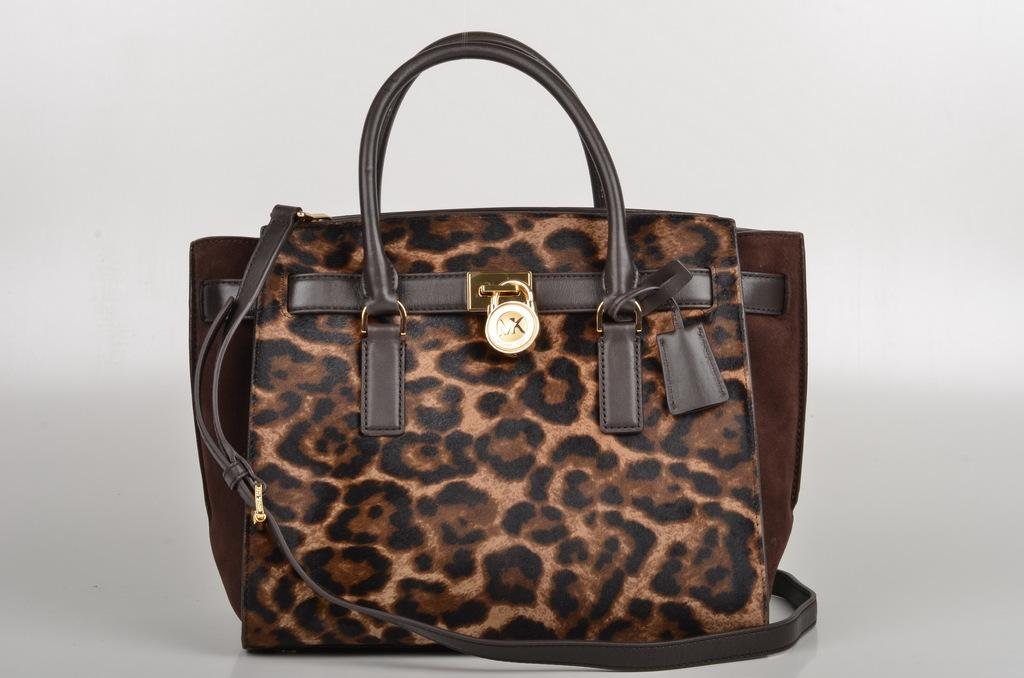What is the main object in the center of the image? There is a bag in the center of the image. What color is the bag? The bag is brown in color. Is the cloth in the bag on fire in the image? There is no cloth or indication of fire present in the image. 